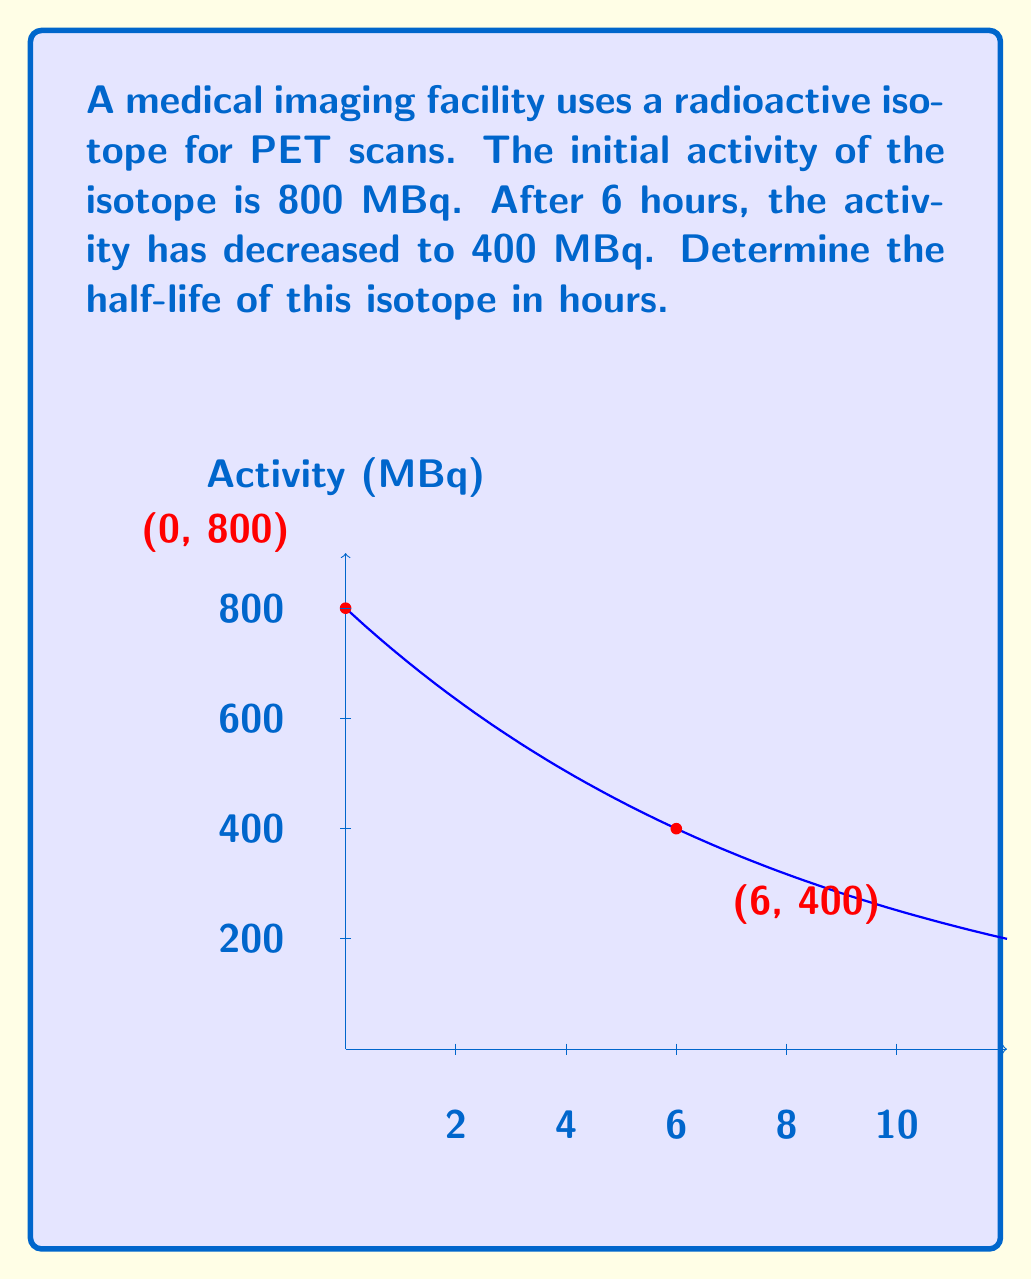Teach me how to tackle this problem. To solve this problem, we'll use the radioactive decay formula and the given information:

1) The radioactive decay formula is:
   $A(t) = A_0 \cdot e^{-\lambda t}$
   where $A(t)$ is the activity at time $t$, $A_0$ is the initial activity, $\lambda$ is the decay constant, and $t$ is time.

2) We know:
   $A_0 = 800$ MBq
   $A(6) = 400$ MBq
   $t = 6$ hours

3) Substituting these values into the formula:
   $400 = 800 \cdot e^{-6\lambda}$

4) Simplify:
   $\frac{1}{2} = e^{-6\lambda}$

5) Take the natural log of both sides:
   $\ln(\frac{1}{2}) = -6\lambda$

6) Solve for $\lambda$:
   $\lambda = \frac{\ln(2)}{6} \approx 0.11552$ per hour

7) The half-life ($t_{1/2}$) is related to $\lambda$ by:
   $t_{1/2} = \frac{\ln(2)}{\lambda}$

8) Substitute the value of $\lambda$:
   $t_{1/2} = \frac{\ln(2)}{\frac{\ln(2)}{6}} = 6$ hours

Therefore, the half-life of the isotope is 6 hours.
Answer: 6 hours 